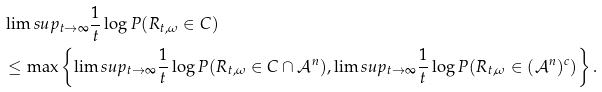Convert formula to latex. <formula><loc_0><loc_0><loc_500><loc_500>& \lim s u p _ { t \rightarrow \infty } \frac { 1 } { t } \log P ( R _ { t , \omega } \in C ) \\ & \leq \max \left \{ \lim s u p _ { t \rightarrow \infty } \frac { 1 } { t } \log P ( R _ { t , \omega } \in C \cap \mathcal { A } ^ { n } ) , \lim s u p _ { t \rightarrow \infty } \frac { 1 } { t } \log P ( R _ { t , \omega } \in ( \mathcal { A } ^ { n } ) ^ { c } ) \right \} .</formula> 